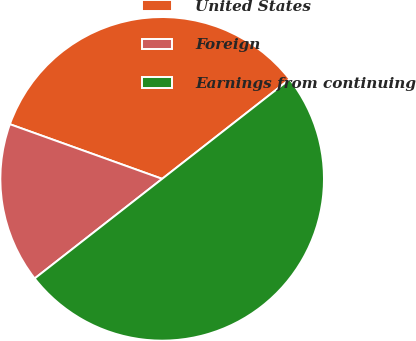<chart> <loc_0><loc_0><loc_500><loc_500><pie_chart><fcel>United States<fcel>Foreign<fcel>Earnings from continuing<nl><fcel>33.96%<fcel>16.04%<fcel>50.0%<nl></chart> 